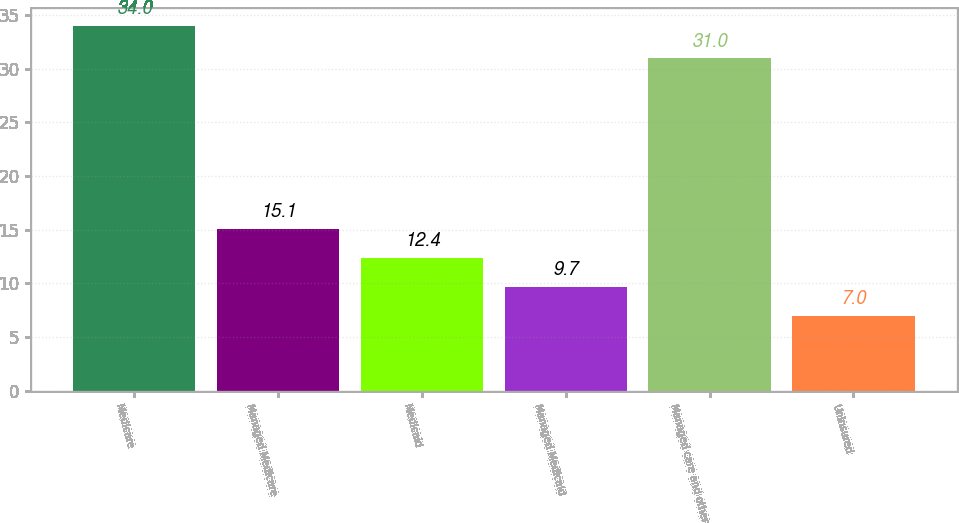Convert chart. <chart><loc_0><loc_0><loc_500><loc_500><bar_chart><fcel>Medicare<fcel>Managed Medicare<fcel>Medicaid<fcel>Managed Medicaid<fcel>Managed care and other<fcel>Uninsured<nl><fcel>34<fcel>15.1<fcel>12.4<fcel>9.7<fcel>31<fcel>7<nl></chart> 